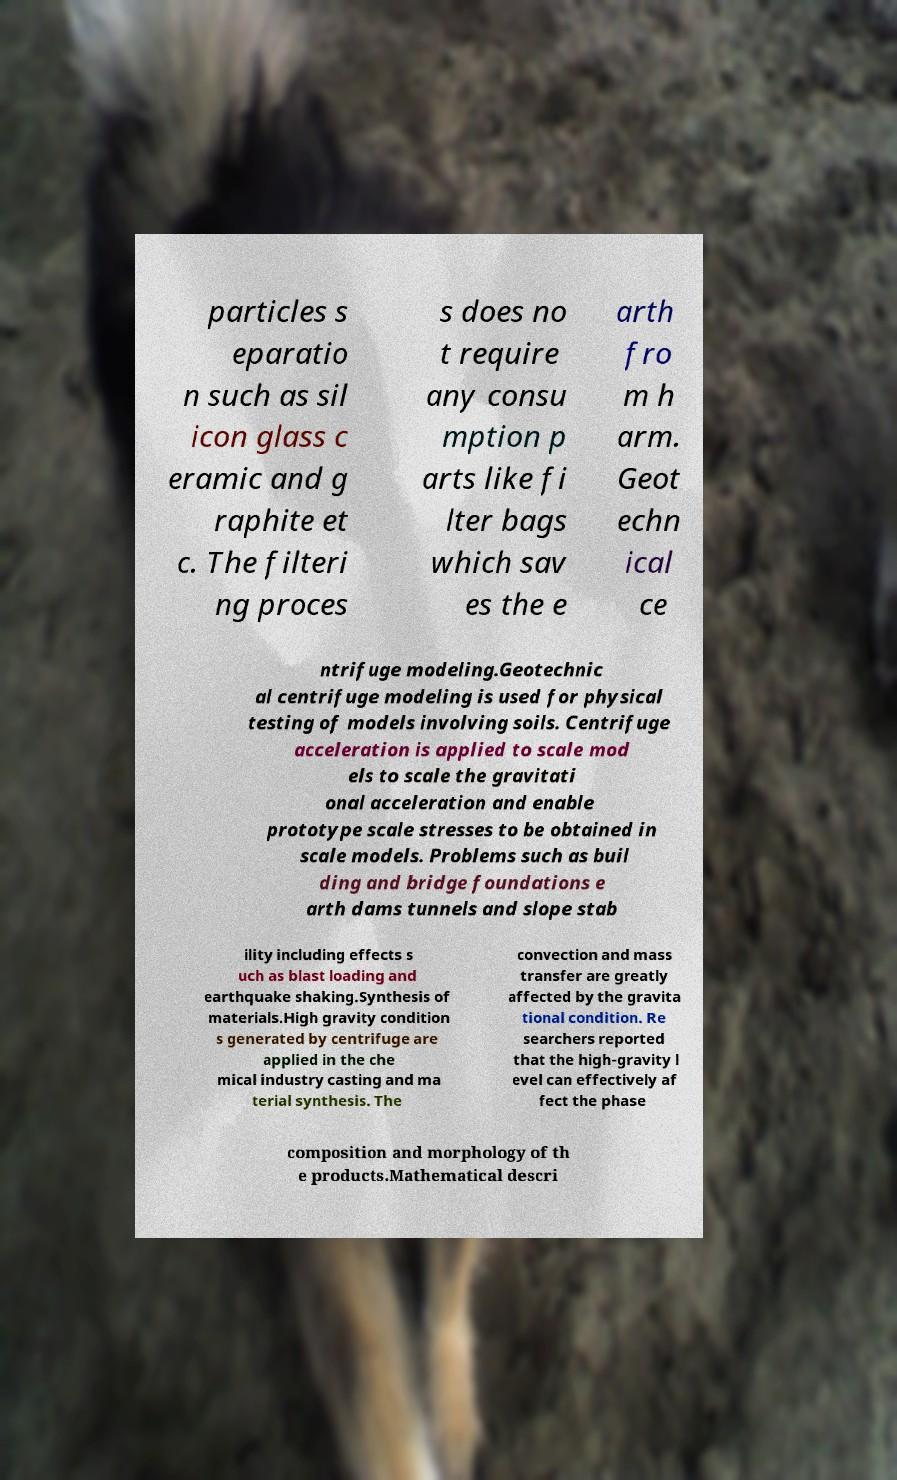What messages or text are displayed in this image? I need them in a readable, typed format. particles s eparatio n such as sil icon glass c eramic and g raphite et c. The filteri ng proces s does no t require any consu mption p arts like fi lter bags which sav es the e arth fro m h arm. Geot echn ical ce ntrifuge modeling.Geotechnic al centrifuge modeling is used for physical testing of models involving soils. Centrifuge acceleration is applied to scale mod els to scale the gravitati onal acceleration and enable prototype scale stresses to be obtained in scale models. Problems such as buil ding and bridge foundations e arth dams tunnels and slope stab ility including effects s uch as blast loading and earthquake shaking.Synthesis of materials.High gravity condition s generated by centrifuge are applied in the che mical industry casting and ma terial synthesis. The convection and mass transfer are greatly affected by the gravita tional condition. Re searchers reported that the high-gravity l evel can effectively af fect the phase composition and morphology of th e products.Mathematical descri 